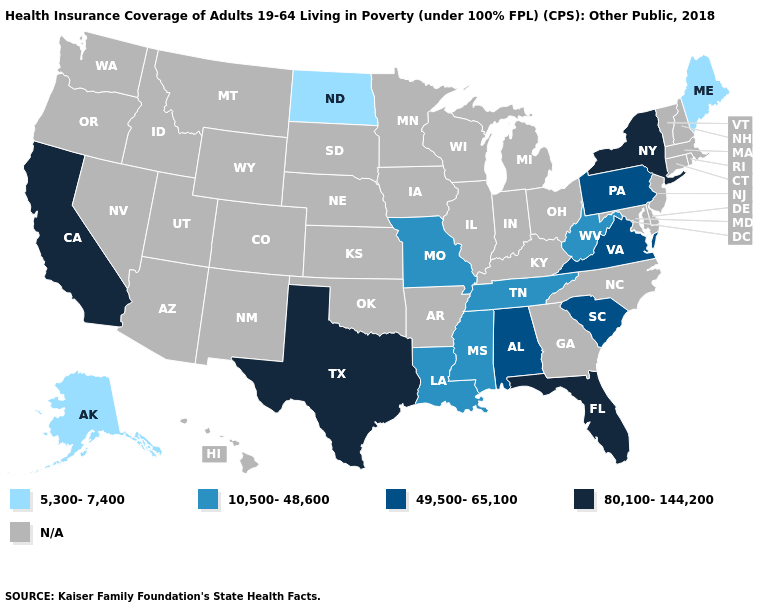What is the lowest value in the USA?
Be succinct. 5,300-7,400. Does the first symbol in the legend represent the smallest category?
Keep it brief. Yes. What is the value of Connecticut?
Be succinct. N/A. What is the value of Arizona?
Short answer required. N/A. Name the states that have a value in the range 10,500-48,600?
Answer briefly. Louisiana, Mississippi, Missouri, Tennessee, West Virginia. What is the value of Colorado?
Keep it brief. N/A. What is the highest value in the USA?
Short answer required. 80,100-144,200. Name the states that have a value in the range 5,300-7,400?
Write a very short answer. Alaska, Maine, North Dakota. What is the lowest value in states that border Oklahoma?
Be succinct. 10,500-48,600. Name the states that have a value in the range 5,300-7,400?
Short answer required. Alaska, Maine, North Dakota. What is the highest value in the USA?
Short answer required. 80,100-144,200. Which states hav the highest value in the Northeast?
Answer briefly. New York. Does North Dakota have the lowest value in the USA?
Be succinct. Yes. 